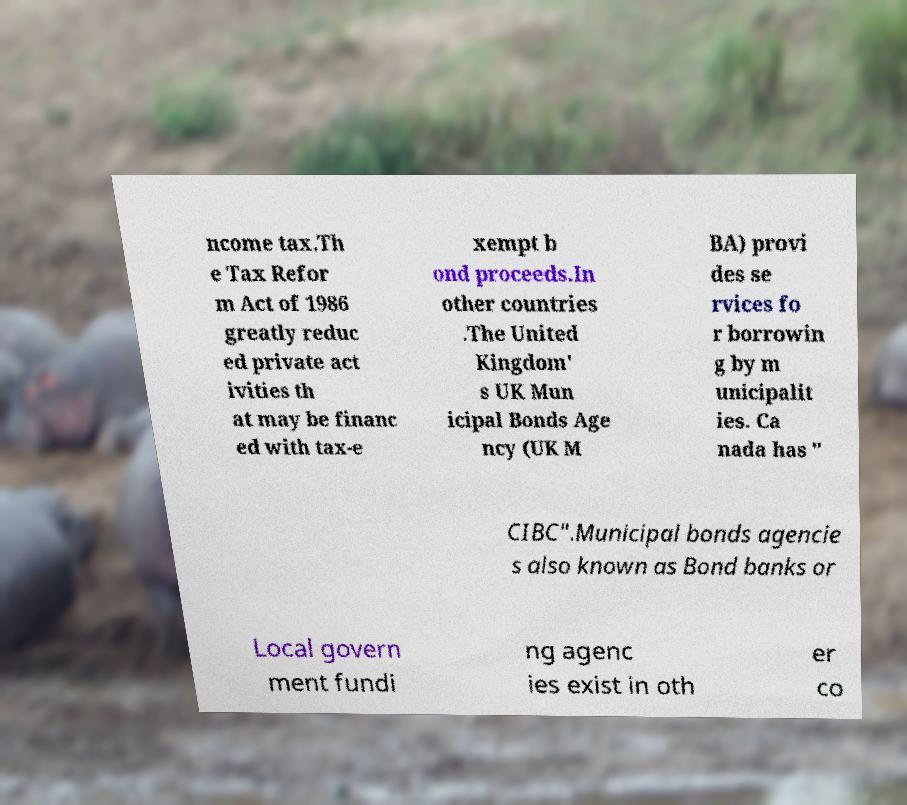There's text embedded in this image that I need extracted. Can you transcribe it verbatim? ncome tax.Th e Tax Refor m Act of 1986 greatly reduc ed private act ivities th at may be financ ed with tax-e xempt b ond proceeds.In other countries .The United Kingdom' s UK Mun icipal Bonds Age ncy (UK M BA) provi des se rvices fo r borrowin g by m unicipalit ies. Ca nada has " CIBC".Municipal bonds agencie s also known as Bond banks or Local govern ment fundi ng agenc ies exist in oth er co 